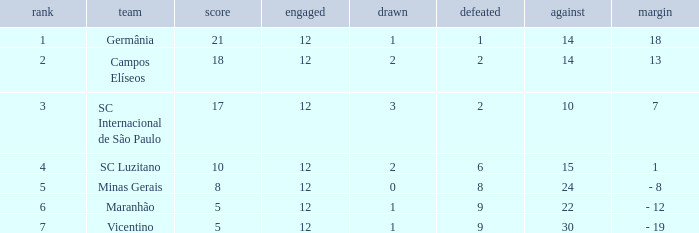What is the sum of drawn that has a played more than 12? 0.0. 